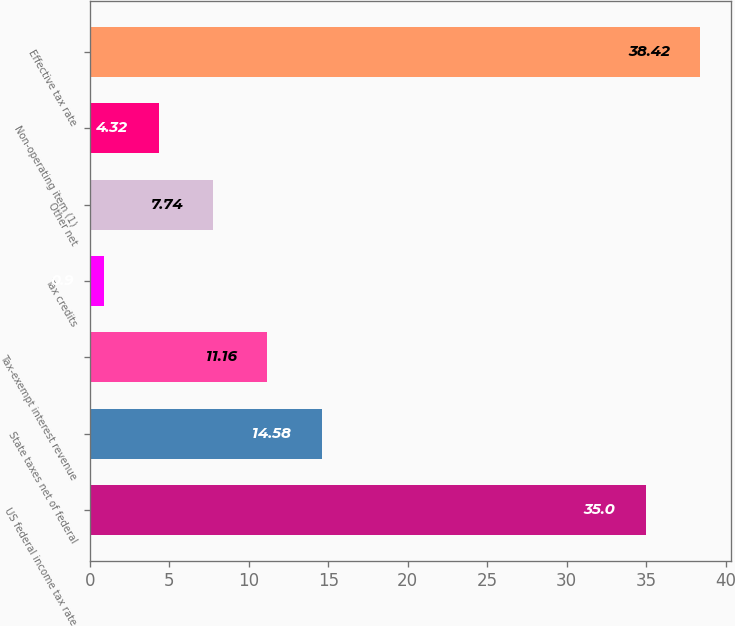Convert chart to OTSL. <chart><loc_0><loc_0><loc_500><loc_500><bar_chart><fcel>US federal income tax rate<fcel>State taxes net of federal<fcel>Tax-exempt interest revenue<fcel>Tax credits<fcel>Other net<fcel>Non-operating item (1)<fcel>Effective tax rate<nl><fcel>35<fcel>14.58<fcel>11.16<fcel>0.9<fcel>7.74<fcel>4.32<fcel>38.42<nl></chart> 